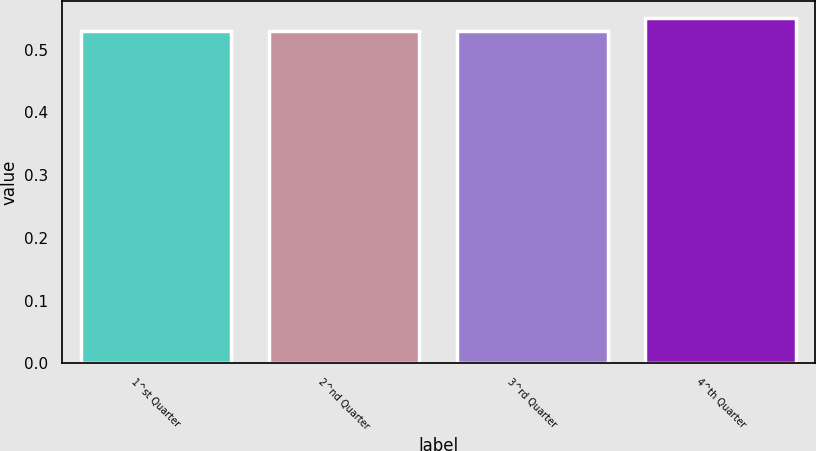Convert chart to OTSL. <chart><loc_0><loc_0><loc_500><loc_500><bar_chart><fcel>1^st Quarter<fcel>2^nd Quarter<fcel>3^rd Quarter<fcel>4^th Quarter<nl><fcel>0.53<fcel>0.53<fcel>0.53<fcel>0.55<nl></chart> 